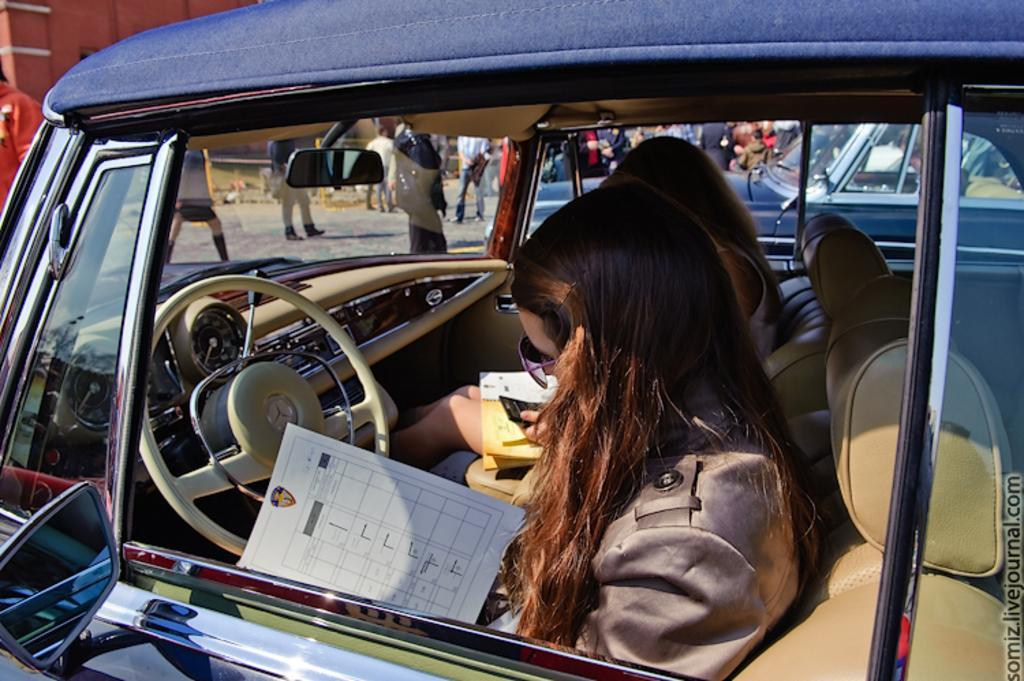Can you describe this image briefly? In this picture we can see two women sitting inside the car and looking in this paper. Beside to the car we can see other vehicle and few persons walking and standing on the road. 